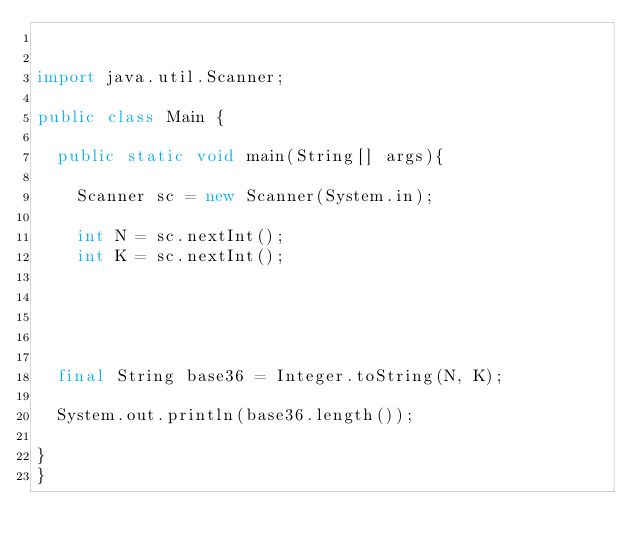<code> <loc_0><loc_0><loc_500><loc_500><_Java_>

import java.util.Scanner;

public class Main {
	
	public static void main(String[] args){

		Scanner sc = new Scanner(System.in);

		int N = sc.nextInt();
		int K = sc.nextInt();
		
		
	
	
	
	final String base36 = Integer.toString(N, K);
	
	System.out.println(base36.length());
	
}
}

</code> 